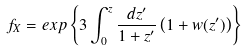Convert formula to latex. <formula><loc_0><loc_0><loc_500><loc_500>f _ { X } = e x p \left \{ 3 \int _ { 0 } ^ { z } \frac { d z ^ { \prime } } { 1 + z ^ { \prime } } \left ( 1 + w ( z ^ { \prime } ) \right ) \right \}</formula> 